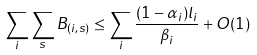Convert formula to latex. <formula><loc_0><loc_0><loc_500><loc_500>\sum _ { i } \sum _ { s } B _ { ( i , s ) } \leq \sum _ { i } \frac { ( 1 - \alpha _ { i } ) l _ { i } } { \beta _ { i } } + O ( 1 )</formula> 